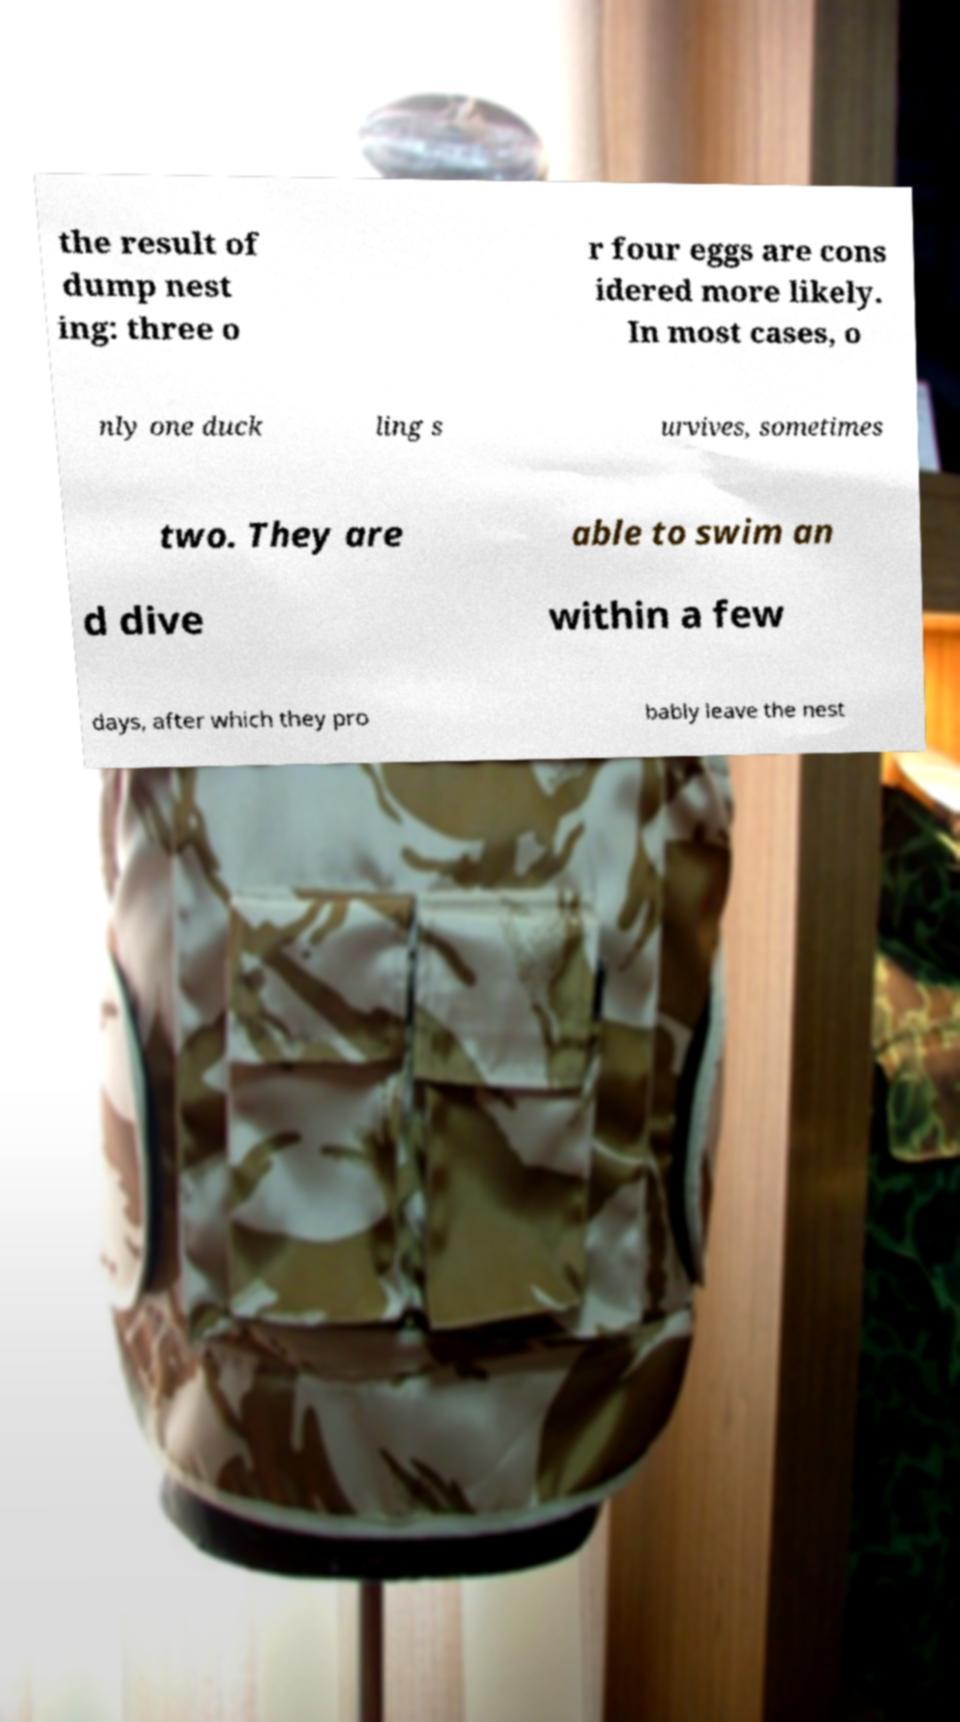Please read and relay the text visible in this image. What does it say? the result of dump nest ing: three o r four eggs are cons idered more likely. In most cases, o nly one duck ling s urvives, sometimes two. They are able to swim an d dive within a few days, after which they pro bably leave the nest 